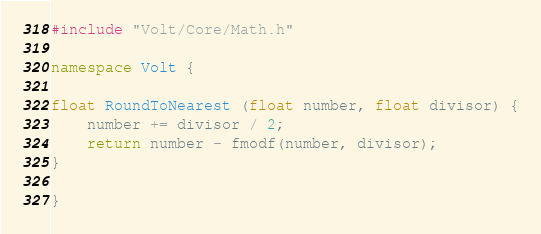<code> <loc_0><loc_0><loc_500><loc_500><_C++_>#include "Volt/Core/Math.h"

namespace Volt {
    
float RoundToNearest (float number, float divisor) {
    number += divisor / 2;
    return number - fmodf(number, divisor);
}

}
</code> 